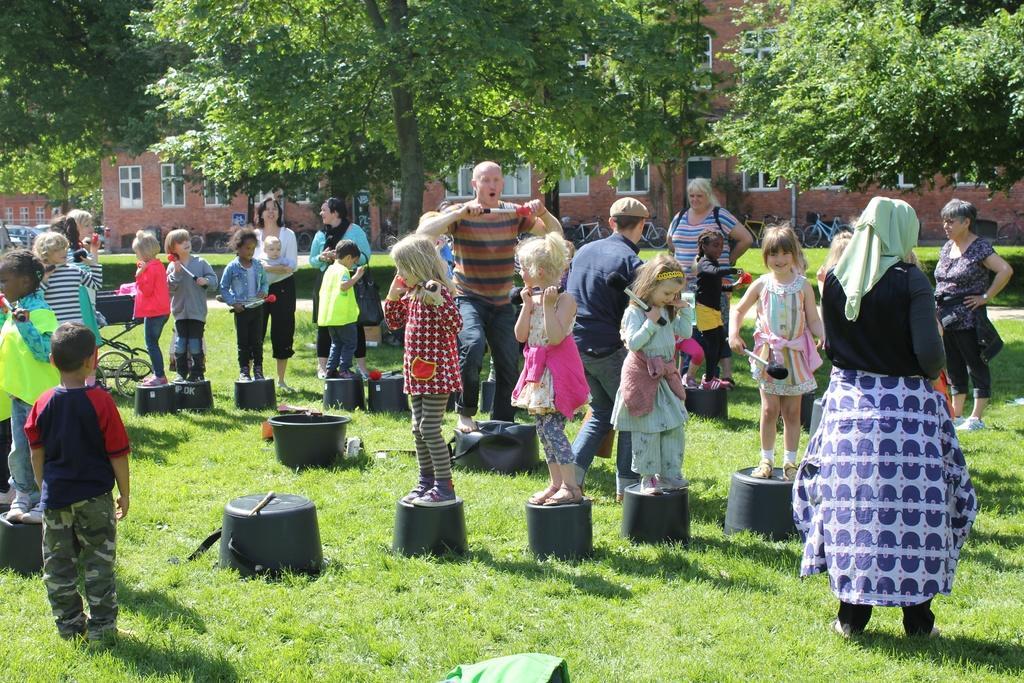Please provide a concise description of this image. In this image there are a group of people, and there are some children and some of them are standing on buckets. At the bottom there is grass, and on the grass there are some objects. And in the background there are houses, trees, cycles and vehicles. 